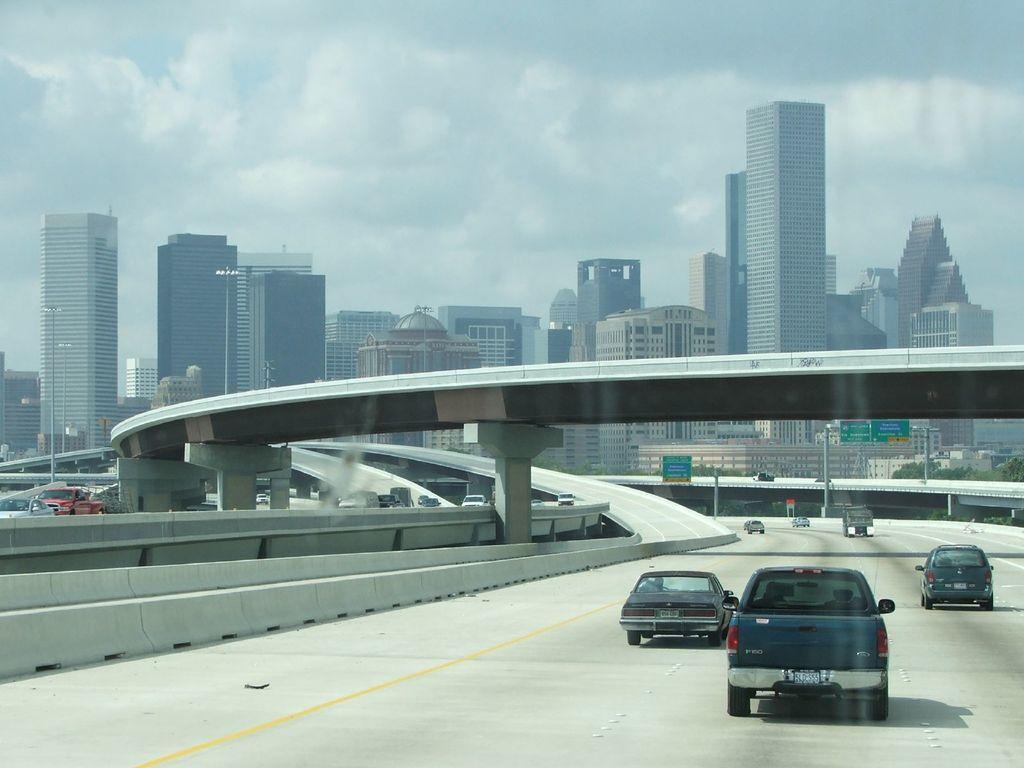In one or two sentences, can you explain what this image depicts? In this image there are some vehicles are on the bottom right side of this image and there is a road at bottom of this image. There is a bridge as we can see in middle of this image and there are some buildings in the background. There is a sky at top of this image. There are some sign boards on the right side to this image. 